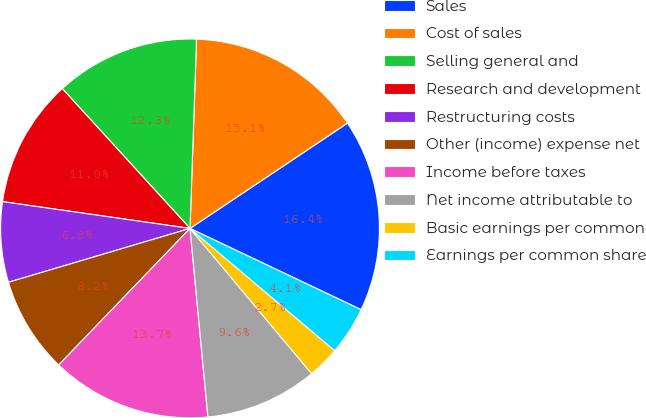<chart> <loc_0><loc_0><loc_500><loc_500><pie_chart><fcel>Sales<fcel>Cost of sales<fcel>Selling general and<fcel>Research and development<fcel>Restructuring costs<fcel>Other (income) expense net<fcel>Income before taxes<fcel>Net income attributable to<fcel>Basic earnings per common<fcel>Earnings per common share<nl><fcel>16.44%<fcel>15.07%<fcel>12.33%<fcel>10.96%<fcel>6.85%<fcel>8.22%<fcel>13.7%<fcel>9.59%<fcel>2.74%<fcel>4.11%<nl></chart> 